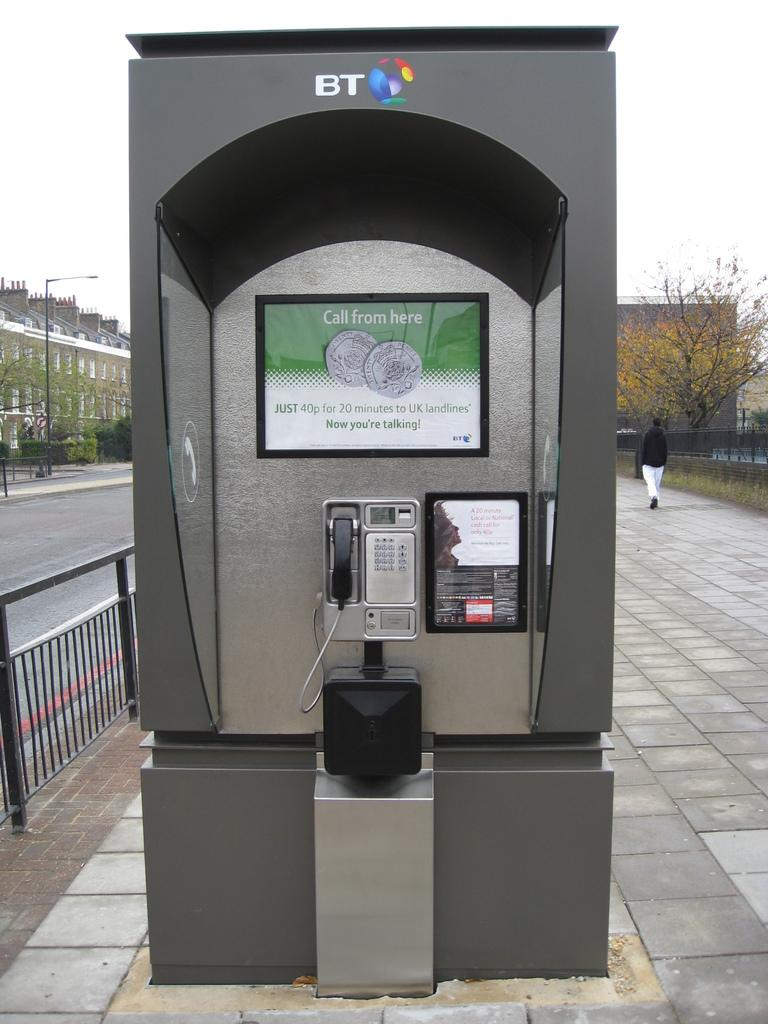<image>
Write a terse but informative summary of the picture. a machine that has a phone on it that has a sign above it that says 'call from here' 